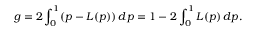Convert formula to latex. <formula><loc_0><loc_0><loc_500><loc_500>g = 2 \int _ { 0 } ^ { 1 } ( p - L ( p ) ) \, d p = 1 - 2 \int _ { 0 } ^ { 1 } L ( p ) \, d p .</formula> 